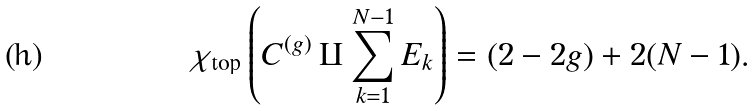Convert formula to latex. <formula><loc_0><loc_0><loc_500><loc_500>\chi _ { \text {top} } \left ( C ^ { ( g ) } \amalg \sum _ { k = 1 } ^ { N - 1 } E _ { k } \right ) = ( 2 - 2 g ) + 2 ( N - 1 ) .</formula> 